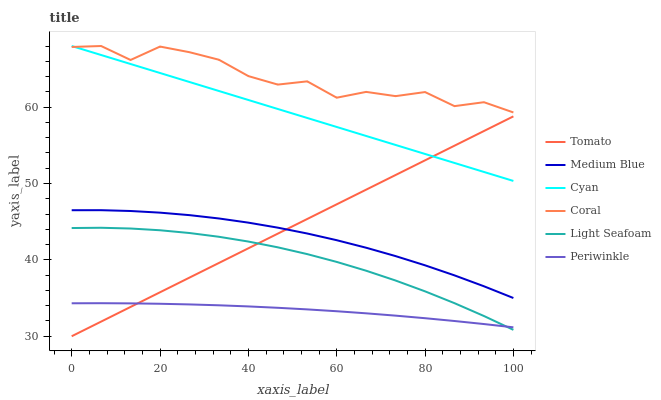Does Periwinkle have the minimum area under the curve?
Answer yes or no. Yes. Does Coral have the maximum area under the curve?
Answer yes or no. Yes. Does Medium Blue have the minimum area under the curve?
Answer yes or no. No. Does Medium Blue have the maximum area under the curve?
Answer yes or no. No. Is Cyan the smoothest?
Answer yes or no. Yes. Is Coral the roughest?
Answer yes or no. Yes. Is Medium Blue the smoothest?
Answer yes or no. No. Is Medium Blue the roughest?
Answer yes or no. No. Does Tomato have the lowest value?
Answer yes or no. Yes. Does Medium Blue have the lowest value?
Answer yes or no. No. Does Cyan have the highest value?
Answer yes or no. Yes. Does Medium Blue have the highest value?
Answer yes or no. No. Is Medium Blue less than Cyan?
Answer yes or no. Yes. Is Coral greater than Light Seafoam?
Answer yes or no. Yes. Does Periwinkle intersect Tomato?
Answer yes or no. Yes. Is Periwinkle less than Tomato?
Answer yes or no. No. Is Periwinkle greater than Tomato?
Answer yes or no. No. Does Medium Blue intersect Cyan?
Answer yes or no. No. 